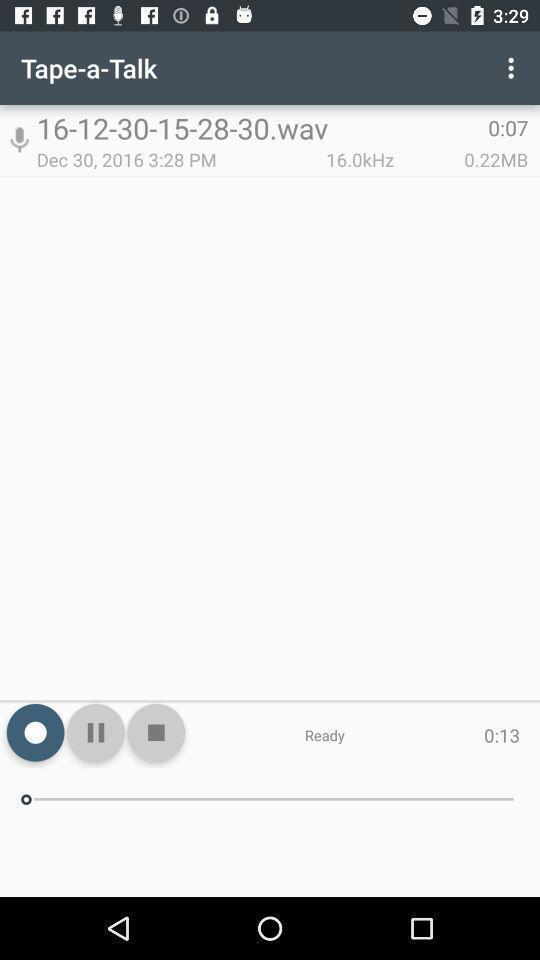Provide a textual representation of this image. Screen showing media player of a recorder app. 